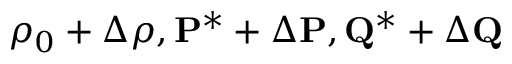Convert formula to latex. <formula><loc_0><loc_0><loc_500><loc_500>\rho _ { 0 } + \Delta \rho , { P ^ { * } } + \Delta { P } , { Q ^ { * } } + \Delta { Q }</formula> 